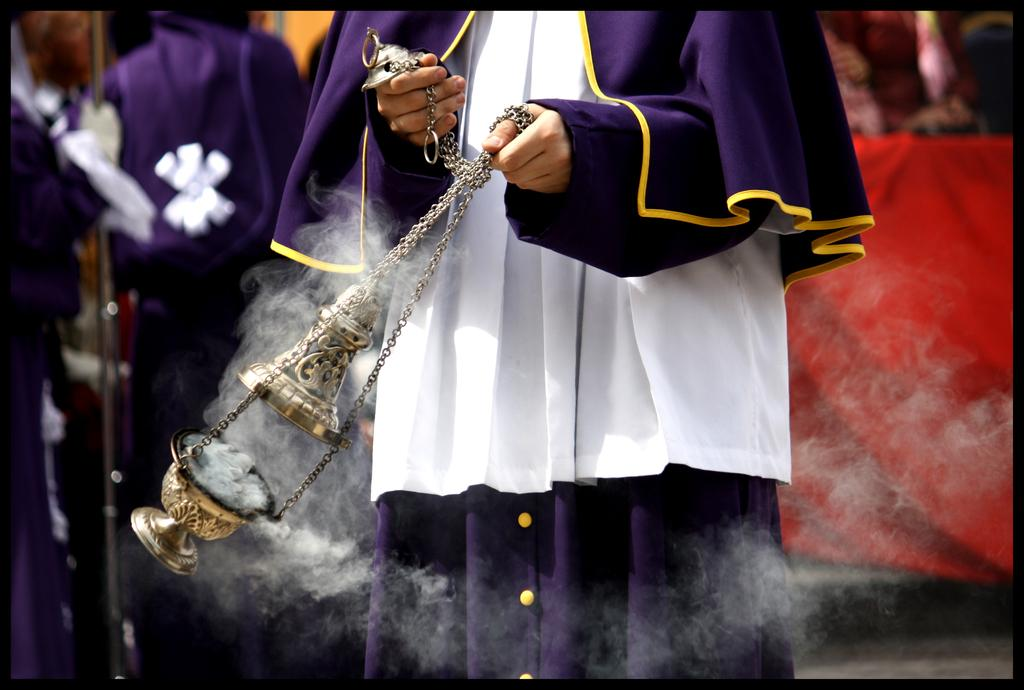What is the person in the image holding in their hands? The person is holding a bell and a bowl in their hands. What color is the cloth on the right side of the image? The cloth on the right side of the image is red. Can you describe the people visible in the background of the image? There are more people visible in the background of the image, but their specific actions or features are not discernible from the provided facts. What type of bee can be seen buzzing around the person's hand in the image? There is no bee present in the image; the person is holding a bell and a bowl in their hands. How does the pest affect the person's hand in the image? There is no mention of a pest affecting the person's hand in the image; the person is holding a bell and a bowl in their hands. 